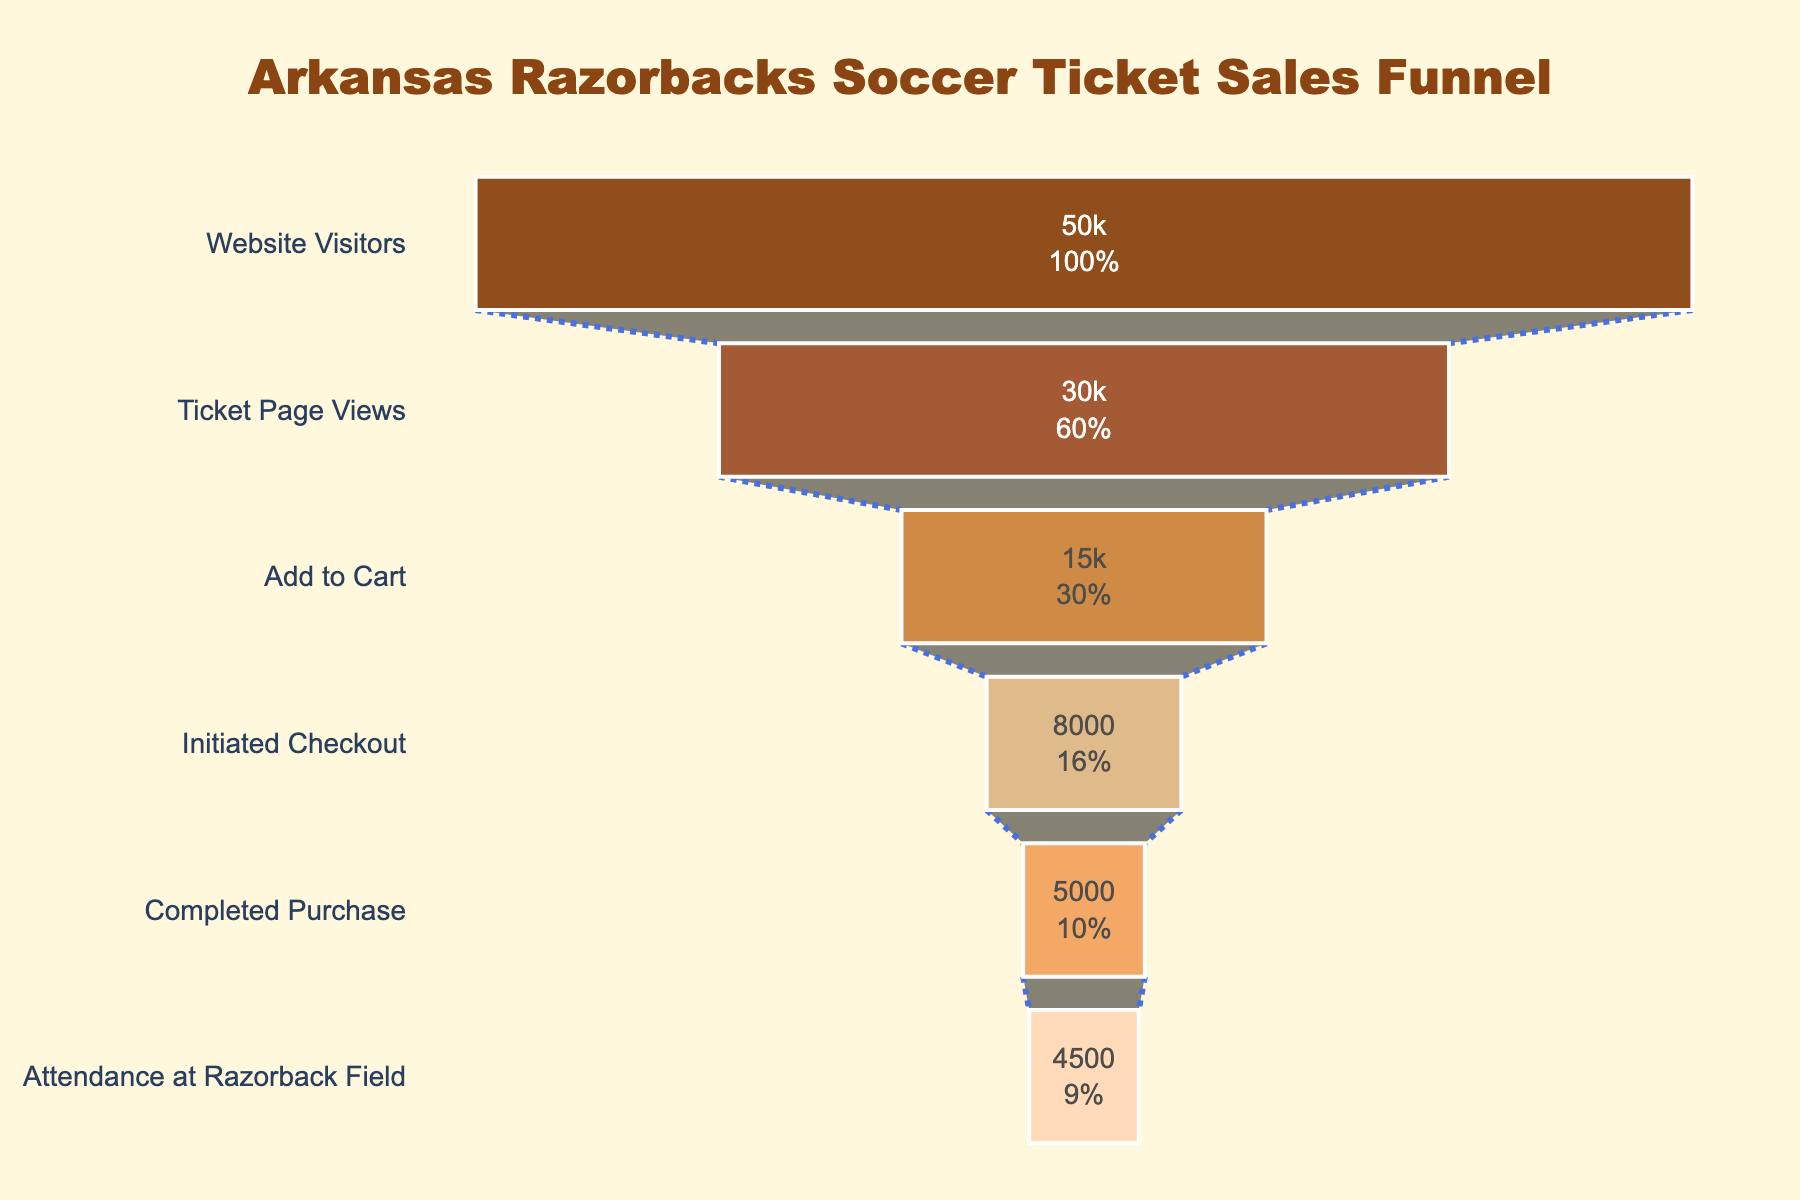What is the title of the chart? The title is displayed at the top center of the chart, indicating what the chart is about.
Answer: "Arkansas Razorbacks Soccer Ticket Sales Funnel" How many stages are there in the funnel? You can count the number of stages listed on the y-axis of the funnel chart. There are six stages in total.
Answer: 6 What is the first stage in the ticket sales funnel? The first stage is the topmost stage of the funnel, labeled on the y-axis.
Answer: "Website Visitors" How many people visited the Ticket Page? The number of people at each stage is labeled inside the corresponding funnel section.
Answer: 30,000 How many more people viewed the Ticket Page compared to those who added tickets to the cart? Subtract the number of people who added tickets to the cart from those who viewed the Ticket Page. 30,000 - 15,000 = 15,000
Answer: 15,000 Which stage has the highest number of people, and which has the lowest? The stage with the highest number is "Website Visitors," and the one with the lowest is "Attendance at Razorback Field."
Answer: Highest: "Website Visitors"; Lowest: "Attendance at Razorback Field" What percentage of people who visited the website completed the purchase? The percentage is calculated by dividing the number who completed the purchase by the number who visited the website and then multiplying by 100. (5,000 / 50,000) * 100 = 10%
Answer: 10% How many stages are there between "Add to Cart" and "Completed Purchase"? Count the number of stages between "Add to Cart" and "Completed Purchase" inclusively.
Answer: 2 How many people attended the Razorback Field compared to those who completed the purchase? Subtract the number of people who attended the Razorback Field from those who completed the purchase. 5,000 - 4,500 = 500
Answer: 500 What colors are used for the "Add to Cart" stage? The colors of each funnel stage are shown on the chart. The "Add to Cart" stage uses a specific shade.
Answer: '#CD853F' 